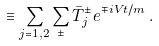Convert formula to latex. <formula><loc_0><loc_0><loc_500><loc_500>\equiv \sum _ { j = 1 , 2 } \sum _ { \pm } \bar { T } _ { j } ^ { \pm } e ^ { \mp i V t / m } \, .</formula> 